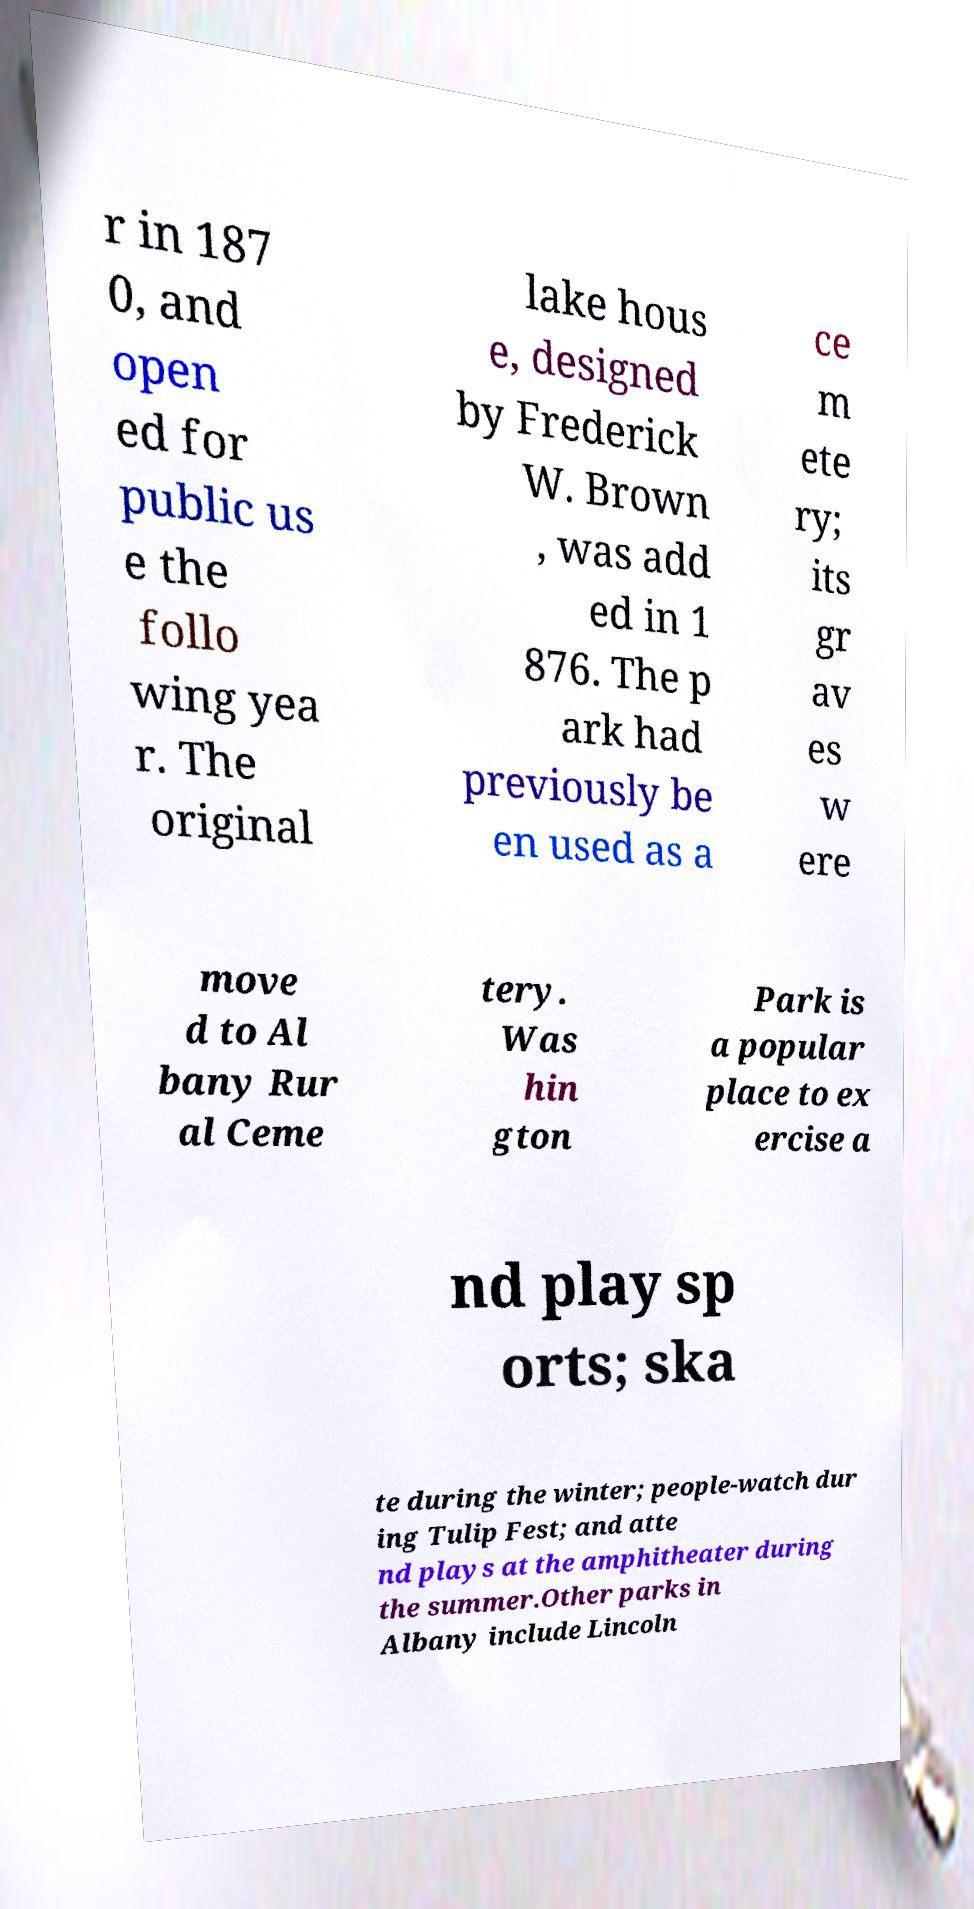Please read and relay the text visible in this image. What does it say? r in 187 0, and open ed for public us e the follo wing yea r. The original lake hous e, designed by Frederick W. Brown , was add ed in 1 876. The p ark had previously be en used as a ce m ete ry; its gr av es w ere move d to Al bany Rur al Ceme tery. Was hin gton Park is a popular place to ex ercise a nd play sp orts; ska te during the winter; people-watch dur ing Tulip Fest; and atte nd plays at the amphitheater during the summer.Other parks in Albany include Lincoln 